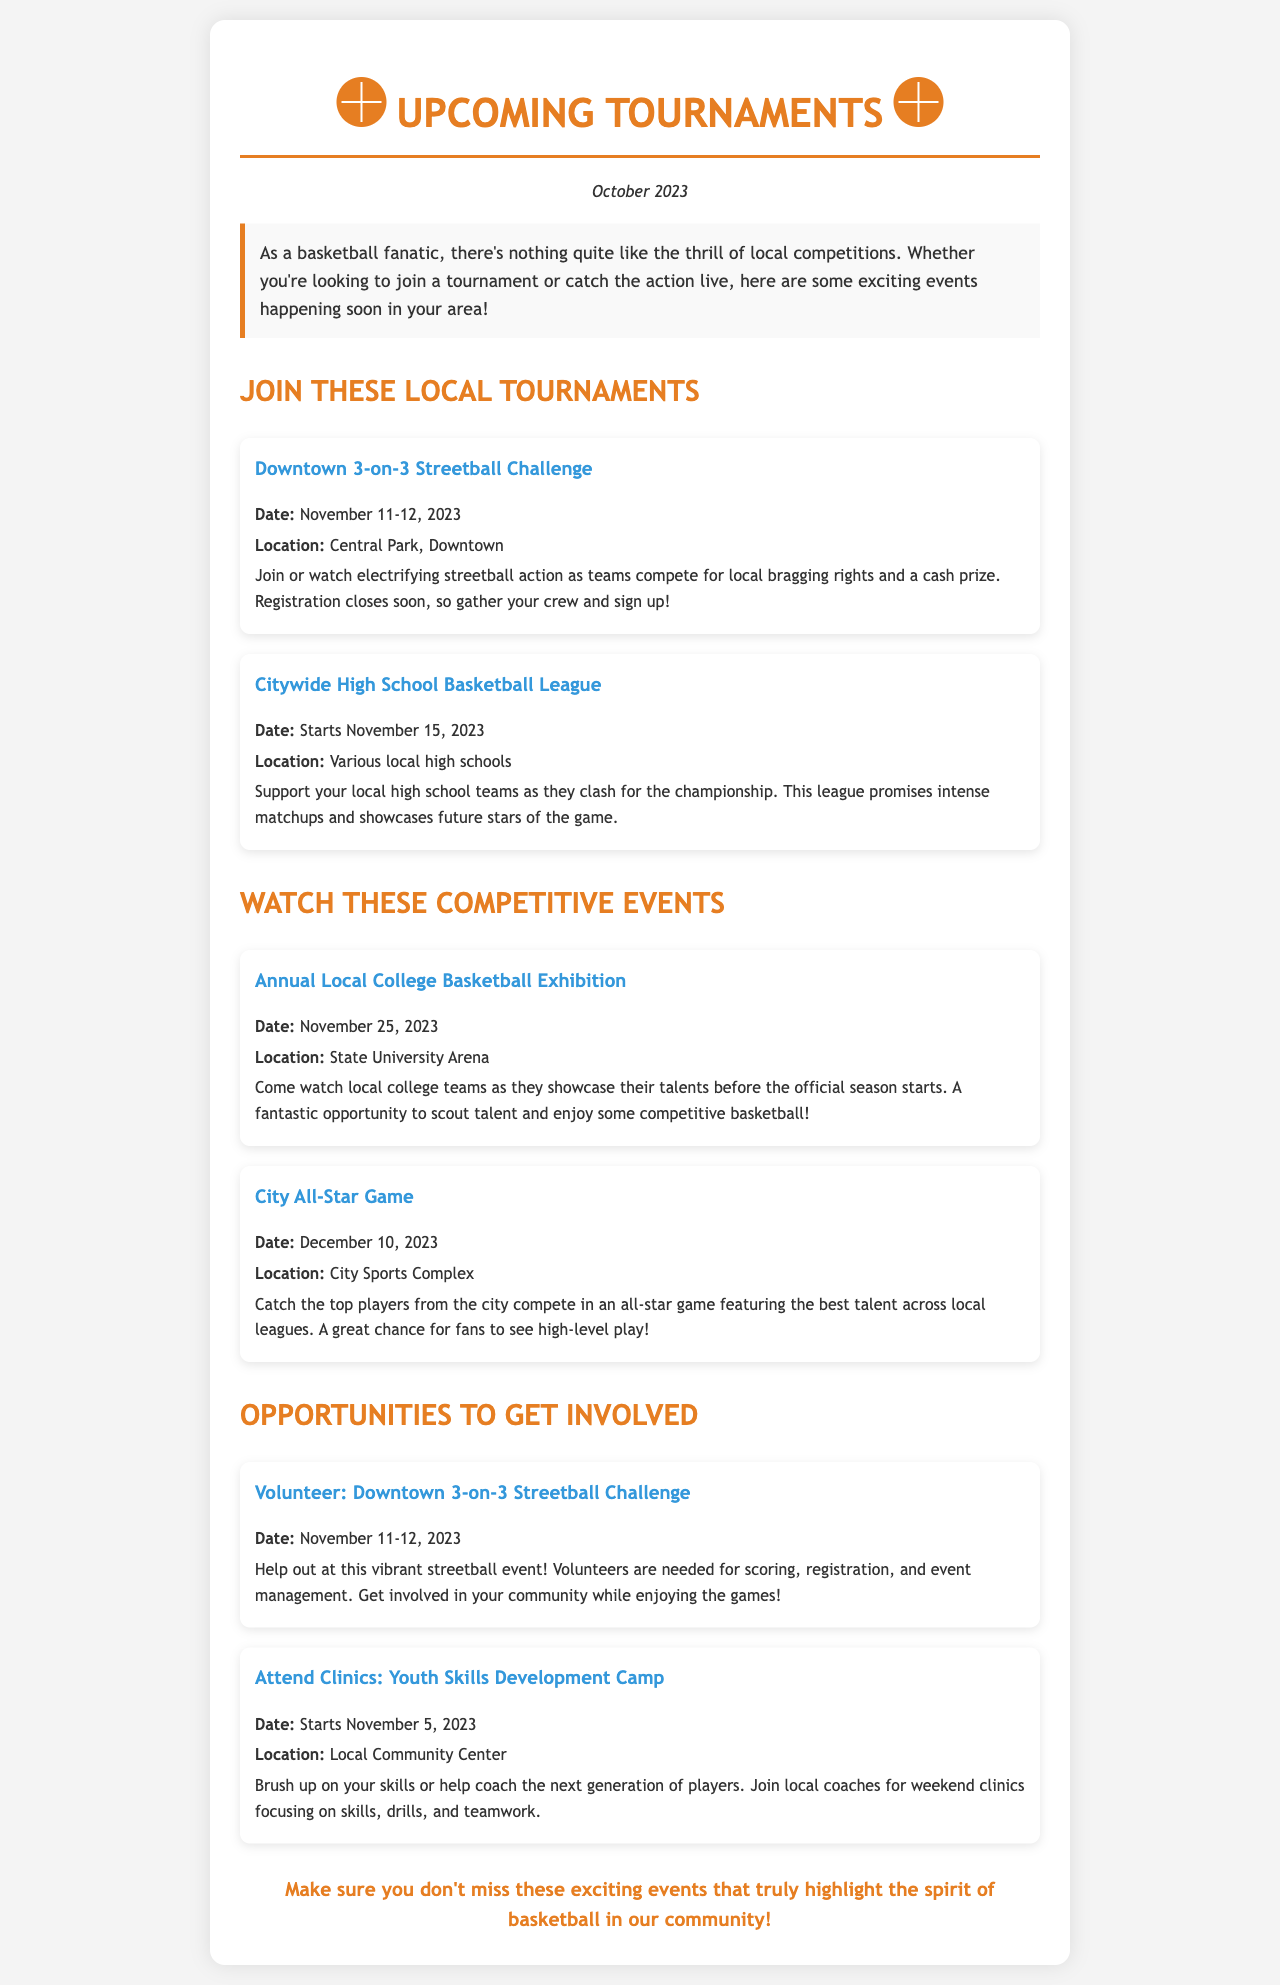What is the date of the Downtown 3-on-3 Streetball Challenge? The date for the Downtown 3-on-3 Streetball Challenge is indicated in the event section as November 11-12, 2023.
Answer: November 11-12, 2023 Where is the City All-Star Game taking place? The location of the City All-Star Game is mentioned in the document, which states it will be at the City Sports Complex.
Answer: City Sports Complex What event starts on November 15, 2023? This question pertains to the event that begins on that date, which is the Citywide High School Basketball League as noted in the schedule.
Answer: Citywide High School Basketball League How many local tournaments are listed in the newsletter? The document provides details about two local tournaments under the "Join These Local Tournaments" section, allowing for a total count.
Answer: 2 What is the focus of the Youth Skills Development Camp? The document describes the Youth Skills Development Camp, which concentrates on skills, drills, and teamwork as part of its offerings.
Answer: Skills, drills, and teamwork What opportunity for involvement is available during the Downtown 3-on-3 Streetball Challenge? The volunteer opportunity mentioned for the Downtown 3-on-3 Streetball Challenge includes helping at the event for various roles.
Answer: Volunteer Which event is aimed at showcasing local college teams? The annual event mentioned that showcases local college teams is highlighted in the document as the Annual Local College Basketball Exhibition.
Answer: Annual Local College Basketball Exhibition When does the Youth Skills Development Camp start? The document specifies the starting date of the Youth Skills Development Camp as November 5, 2023.
Answer: November 5, 2023 What type of event is the Citywide High School Basketball League? This event is categorized as a competitive league where local high school teams compete against each other, indicating its nature.
Answer: League 